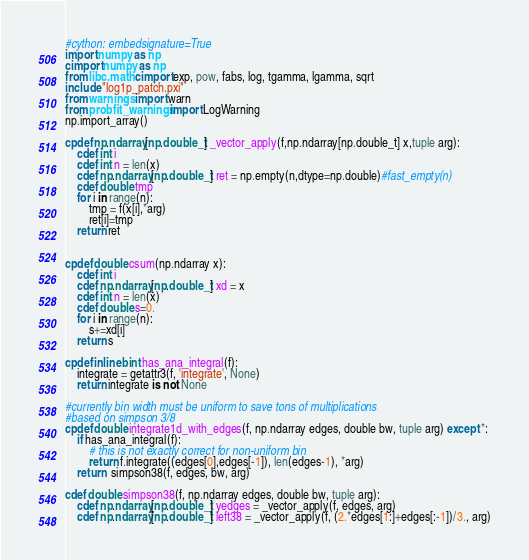Convert code to text. <code><loc_0><loc_0><loc_500><loc_500><_Cython_>#cython: embedsignature=True
import numpy as np
cimport numpy as np
from libc.math cimport exp, pow, fabs, log, tgamma, lgamma, sqrt
include "log1p_patch.pxi"
from warnings import warn
from probfit_warnings import LogWarning
np.import_array()

cpdef np.ndarray[np.double_t] _vector_apply(f,np.ndarray[np.double_t] x,tuple arg):
    cdef int i
    cdef int n = len(x)
    cdef np.ndarray[np.double_t] ret = np.empty(n,dtype=np.double)#fast_empty(n)
    cdef double tmp
    for i in range(n):
        tmp = f(x[i],*arg)
        ret[i]=tmp
    return ret


cpdef double csum(np.ndarray x):
    cdef int i
    cdef np.ndarray[np.double_t] xd = x
    cdef int n = len(x)
    cdef double s=0.
    for i in range(n):
        s+=xd[i]
    return s

cpdef inline bint has_ana_integral(f):
    integrate = getattr3(f, 'integrate', None)
    return integrate is not None

#currently bin width must be uniform to save tons of multiplications
#based on simpson 3/8
cpdef double integrate1d_with_edges(f, np.ndarray edges, double bw, tuple arg) except *:
    if has_ana_integral(f):
        # this is not exactly correct for non-uniform bin
        return f.integrate((edges[0],edges[-1]), len(edges-1), *arg)
    return  simpson38(f, edges, bw, arg)

cdef double simpson38(f, np.ndarray edges, double bw, tuple arg):
    cdef np.ndarray[np.double_t] yedges = _vector_apply(f, edges, arg)
    cdef np.ndarray[np.double_t] left38 = _vector_apply(f, (2.*edges[1:]+edges[:-1])/3., arg)</code> 